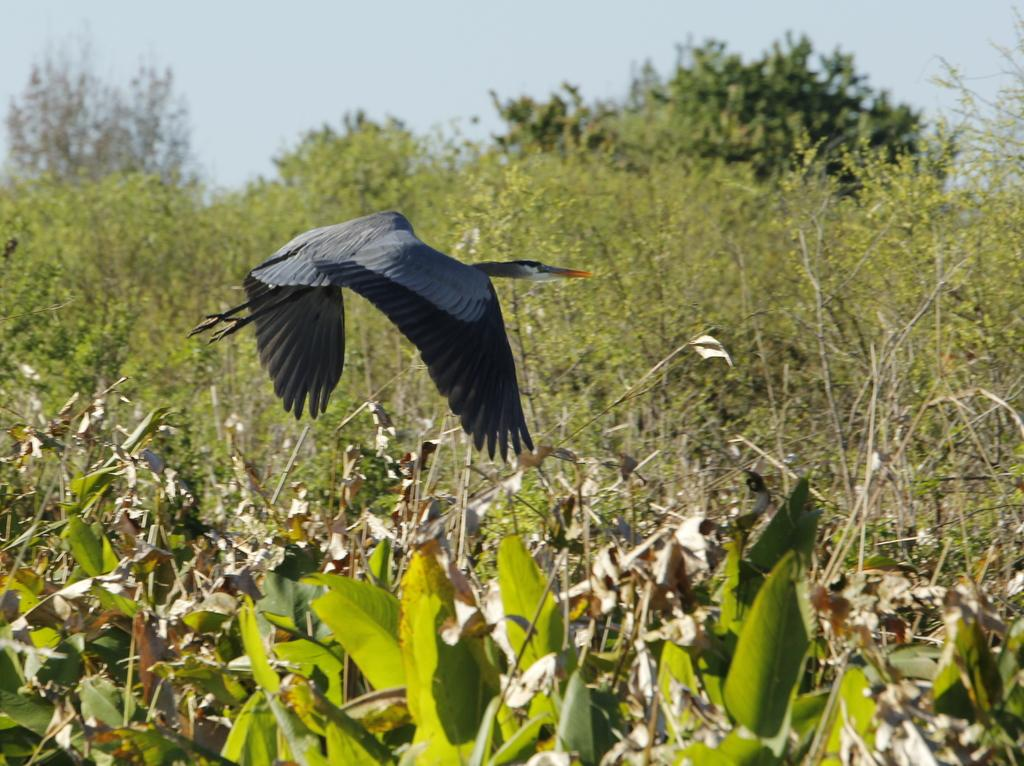What type of living organisms are at the bottom of the image? There are plants at the bottom of the image. What is happening in the middle of the image? A bird is flying in the middle of the image. What can be seen behind the bird? There are trees visible behind the bird. What is visible at the top of the image? The sky is visible at the top of the image. What type of calculator is being used by the committee in the image? There is no calculator or committee present in the image. What is the bird's journey in the image? The image does not depict a journey; it simply shows a bird flying. 